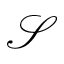<formula> <loc_0><loc_0><loc_500><loc_500>\mathcal { S }</formula> 